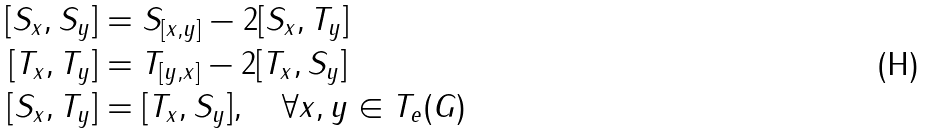Convert formula to latex. <formula><loc_0><loc_0><loc_500><loc_500>[ S _ { x } , S _ { y } ] & = S _ { [ x , y ] } - 2 [ S _ { x } , T _ { y } ] \\ [ T _ { x } , T _ { y } ] & = T _ { [ y , x ] } - 2 [ T _ { x } , S _ { y } ] \\ [ S _ { x } , T _ { y } ] & = [ T _ { x } , S _ { y } ] , \quad \forall x , y \in T _ { e } ( G )</formula> 